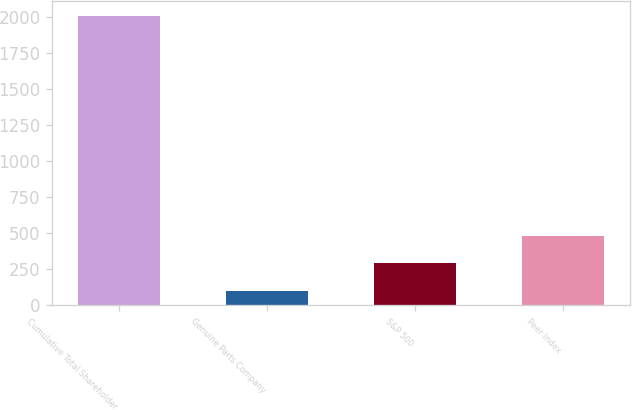Convert chart. <chart><loc_0><loc_0><loc_500><loc_500><bar_chart><fcel>Cumulative Total Shareholder<fcel>Genuine Parts Company<fcel>S&P 500<fcel>Peer Index<nl><fcel>2010<fcel>100<fcel>291<fcel>482<nl></chart> 